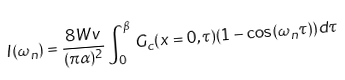Convert formula to latex. <formula><loc_0><loc_0><loc_500><loc_500>I ( \omega _ { n } ) = \frac { 8 W v } { ( \pi \alpha ) ^ { 2 } } \int _ { 0 } ^ { \beta } G _ { c } ( x = 0 , \tau ) ( 1 - \cos ( \omega _ { n } \tau ) ) d \tau</formula> 